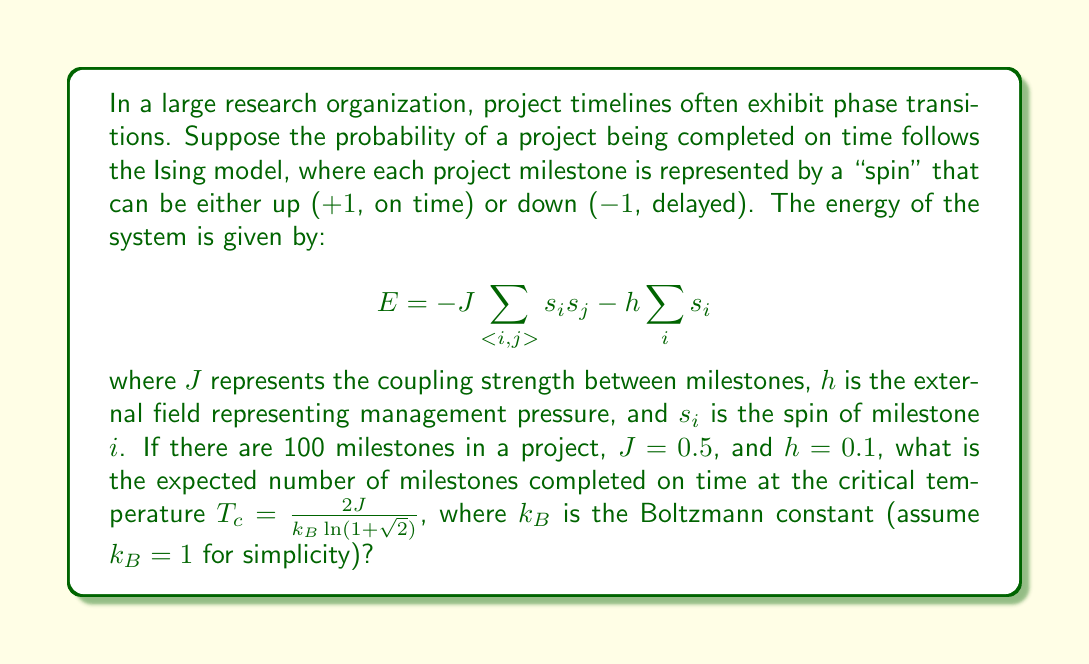Help me with this question. To solve this problem, we'll follow these steps:

1) First, we need to calculate the critical temperature $T_c$:

   $$T_c = \frac{2J}{k_B \ln(1+\sqrt{2})} = \frac{2(0.5)}{1 \cdot \ln(1+\sqrt{2})} \approx 2.269$$

2) At the critical temperature, the system is at the phase transition point. In the Ising model, this means that the magnetization (which in our case represents the average state of the milestones) is zero in the absence of an external field.

3) However, we have a non-zero external field $h = 0.1$. This breaks the symmetry and causes a slight bias towards the positive state.

4) To calculate the expected number of milestones completed on time, we need to find the average magnetization $\langle m \rangle$ at $T_c$ with this small external field.

5) For small $h$ near $T_c$, the magnetization follows the power law:

   $$\langle m \rangle \approx (h/T_c)^{1/\delta}$$

   where $\delta = 15$ for the 2D Ising model.

6) Plugging in our values:

   $$\langle m \rangle \approx (0.1/2.269)^{1/15} \approx 0.8414$$

7) This magnetization represents the average spin. To convert this to the number of milestones, we need to:
   - Add 1 (to convert from [-1,1] range to [0,2])
   - Divide by 2 (to get a proportion between 0 and 1)
   - Multiply by the total number of milestones

8) Therefore, the expected number of milestones completed on time is:

   $$N_{on time} = 100 \cdot \frac{\langle m \rangle + 1}{2} = 100 \cdot \frac{0.8414 + 1}{2} \approx 92.07$$
Answer: 92 milestones (rounded to nearest whole number) 